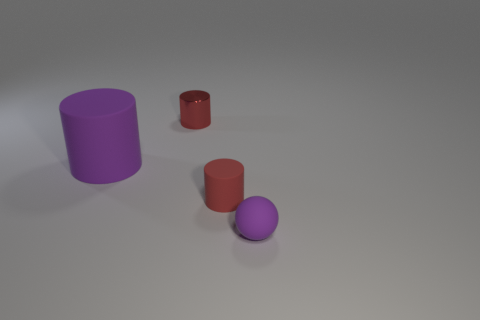Subtract all red matte cylinders. How many cylinders are left? 2 Subtract all purple cylinders. How many cylinders are left? 2 Subtract all cylinders. How many objects are left? 1 Subtract all small purple rubber objects. Subtract all big green objects. How many objects are left? 3 Add 1 small cylinders. How many small cylinders are left? 3 Add 4 cylinders. How many cylinders exist? 7 Add 1 big matte cylinders. How many objects exist? 5 Subtract 0 yellow cylinders. How many objects are left? 4 Subtract 1 spheres. How many spheres are left? 0 Subtract all yellow cylinders. Subtract all blue cubes. How many cylinders are left? 3 